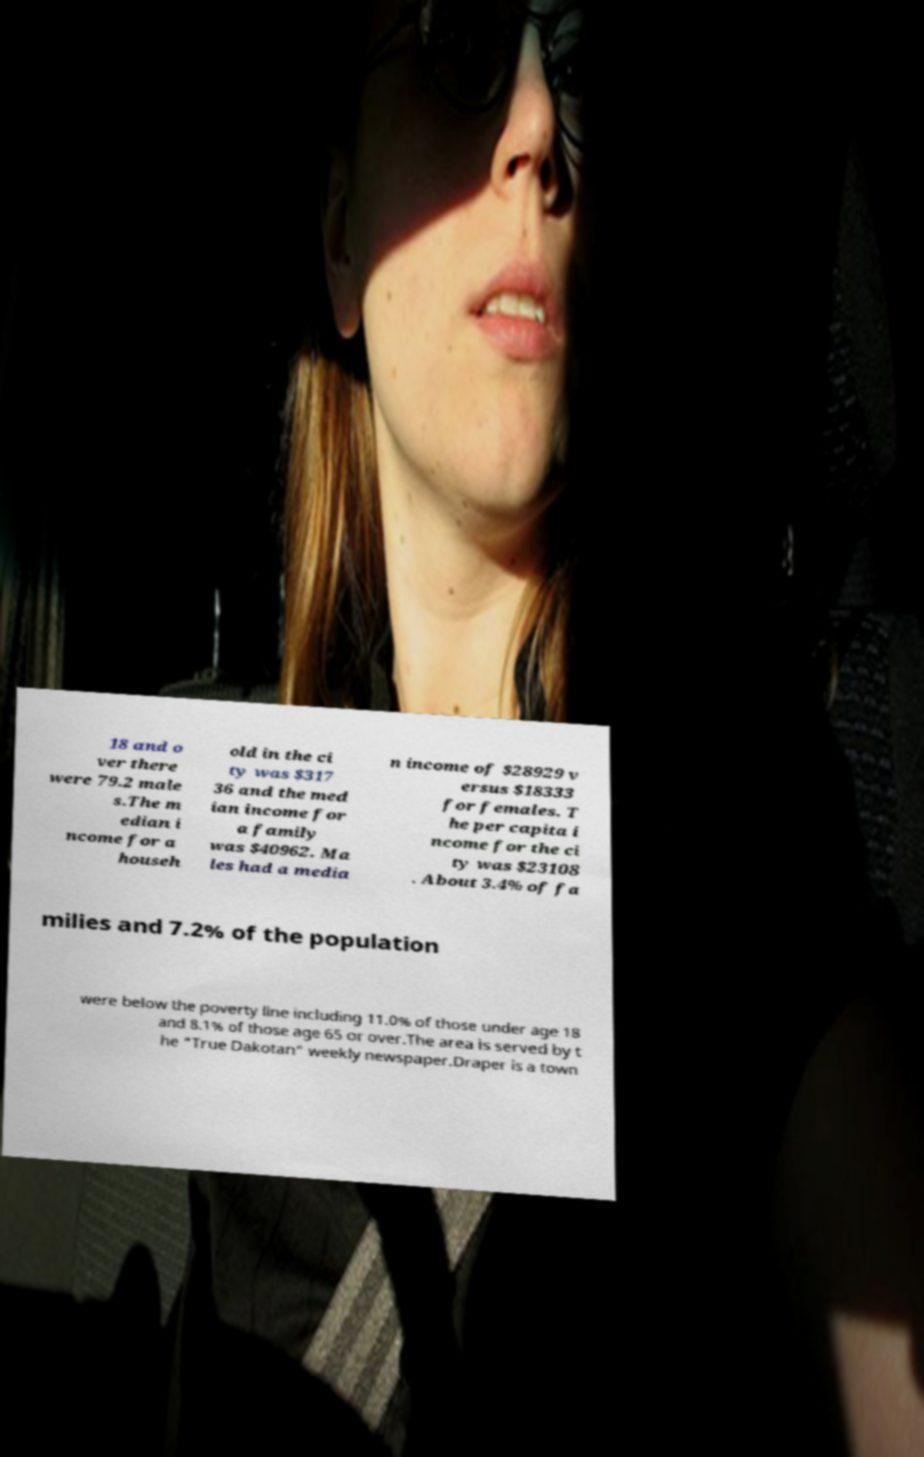Please identify and transcribe the text found in this image. 18 and o ver there were 79.2 male s.The m edian i ncome for a househ old in the ci ty was $317 36 and the med ian income for a family was $40962. Ma les had a media n income of $28929 v ersus $18333 for females. T he per capita i ncome for the ci ty was $23108 . About 3.4% of fa milies and 7.2% of the population were below the poverty line including 11.0% of those under age 18 and 8.1% of those age 65 or over.The area is served by t he "True Dakotan" weekly newspaper.Draper is a town 